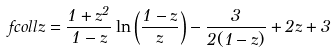Convert formula to latex. <formula><loc_0><loc_0><loc_500><loc_500>f c o l l z = \frac { 1 + z ^ { 2 } } { 1 - z } \ln \left ( \frac { 1 - z } { z } \right ) - \frac { 3 } { 2 ( 1 - z ) } + 2 z + 3</formula> 